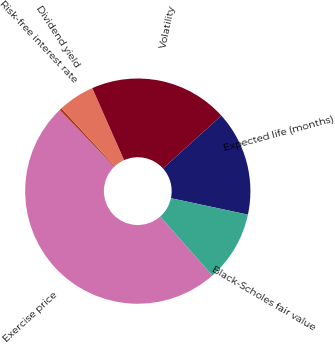<chart> <loc_0><loc_0><loc_500><loc_500><pie_chart><fcel>Exercise price<fcel>Risk-free interest rate<fcel>Dividend yield<fcel>Volatility<fcel>Expected life (months)<fcel>Black-Scholes fair value<nl><fcel>49.32%<fcel>0.34%<fcel>5.24%<fcel>19.93%<fcel>15.03%<fcel>10.14%<nl></chart> 